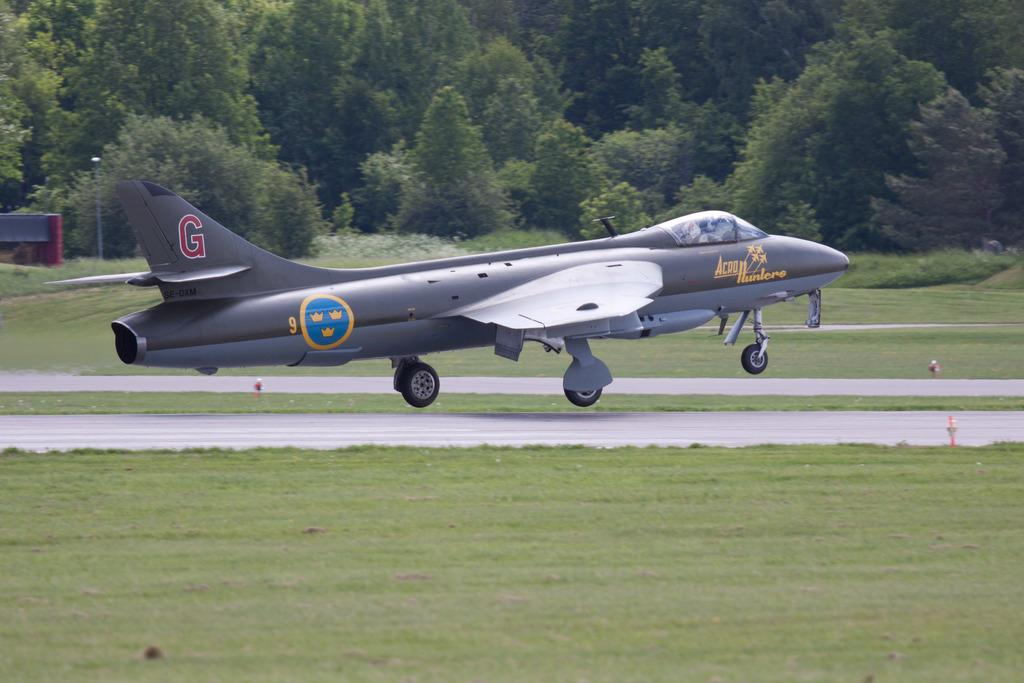<image>
Give a short and clear explanation of the subsequent image. A black airplane with the letter G on the back of the wing of the airplane. 